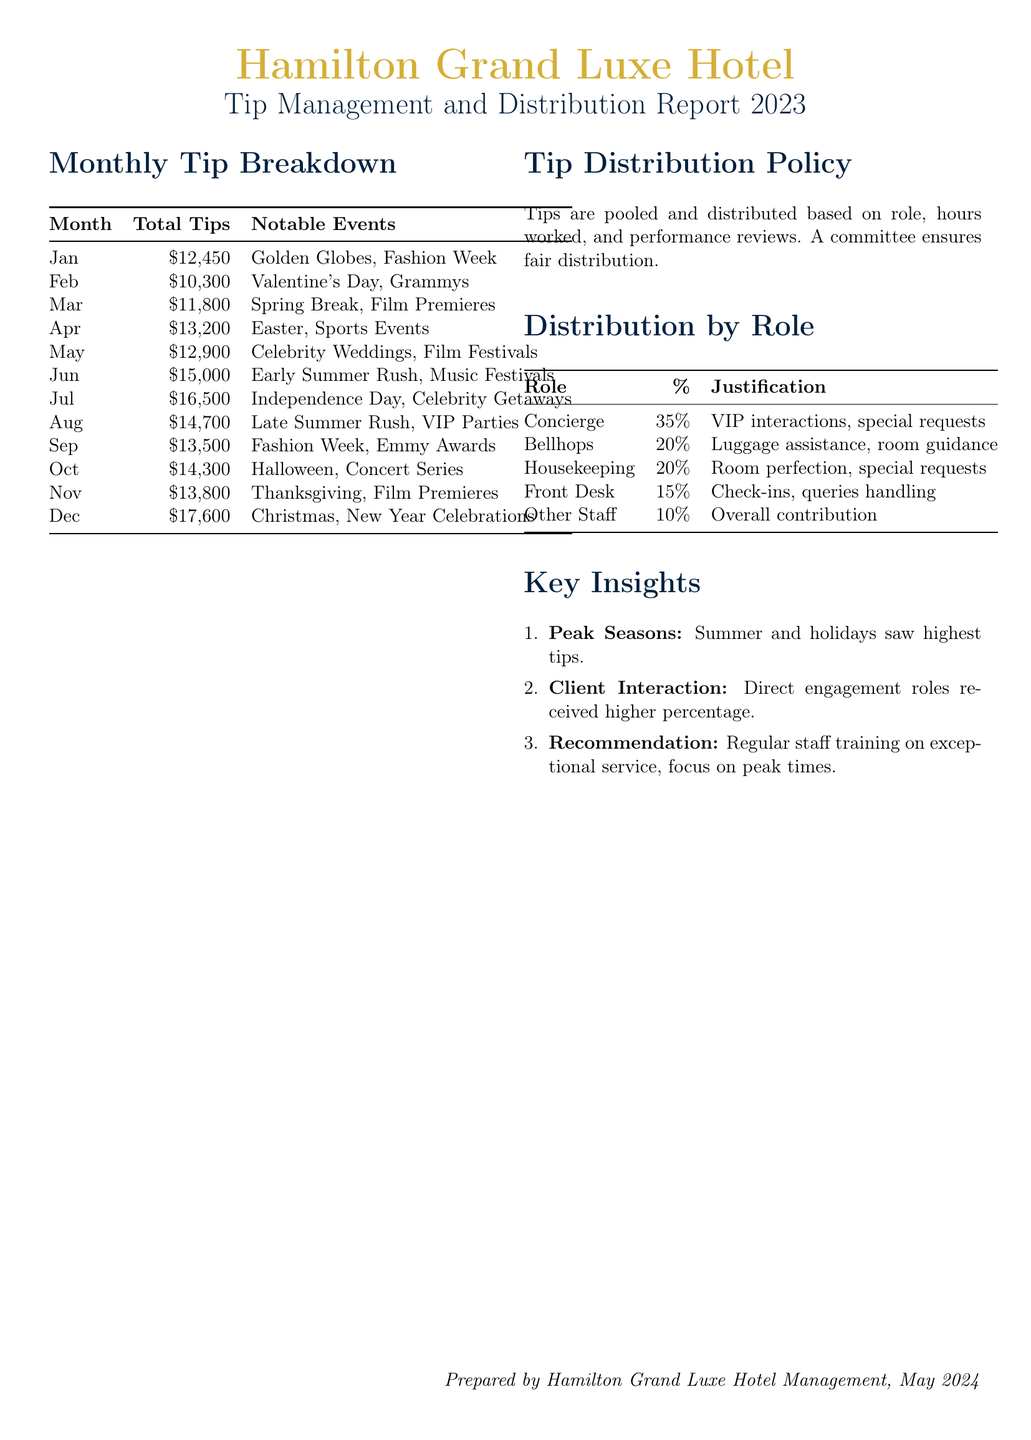What is the total tips for June? The total tips for June is directly mentioned in the monthly breakdown as $15,000.
Answer: $15,000 What notable event occurred in October? The notable event in October is Halloween and Concert Series.
Answer: Halloween, Concert Series What percentage of tips does the concierge receive? The percentage allocated to the concierge role is specified as 35%.
Answer: 35% Which month had the highest total tips? The highest total tips were recorded in December, which is stated as $17,600.
Answer: $17,600 What is the distribution percentage for housekeeping? The percentage allocated for housekeeping is mentioned as 20%.
Answer: 20% Which month includes Thanksgiving? The month that includes Thanksgiving is mentioned as November.
Answer: November What is the justifying factor for the concierge's tip allocation? The justification for the concierge's tip allocation is given as VIP interactions and special requests.
Answer: VIP interactions, special requests What was the total tips for July? The total tips for July are explicitly stated as $16,500.
Answer: $16,500 What does the tip distribution policy mention about the distribution process? The policy mentions that tips are pooled and distributed based on role, hours worked, and performance reviews.
Answer: Pooled, role, hours, performance 